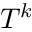Convert formula to latex. <formula><loc_0><loc_0><loc_500><loc_500>T ^ { k }</formula> 